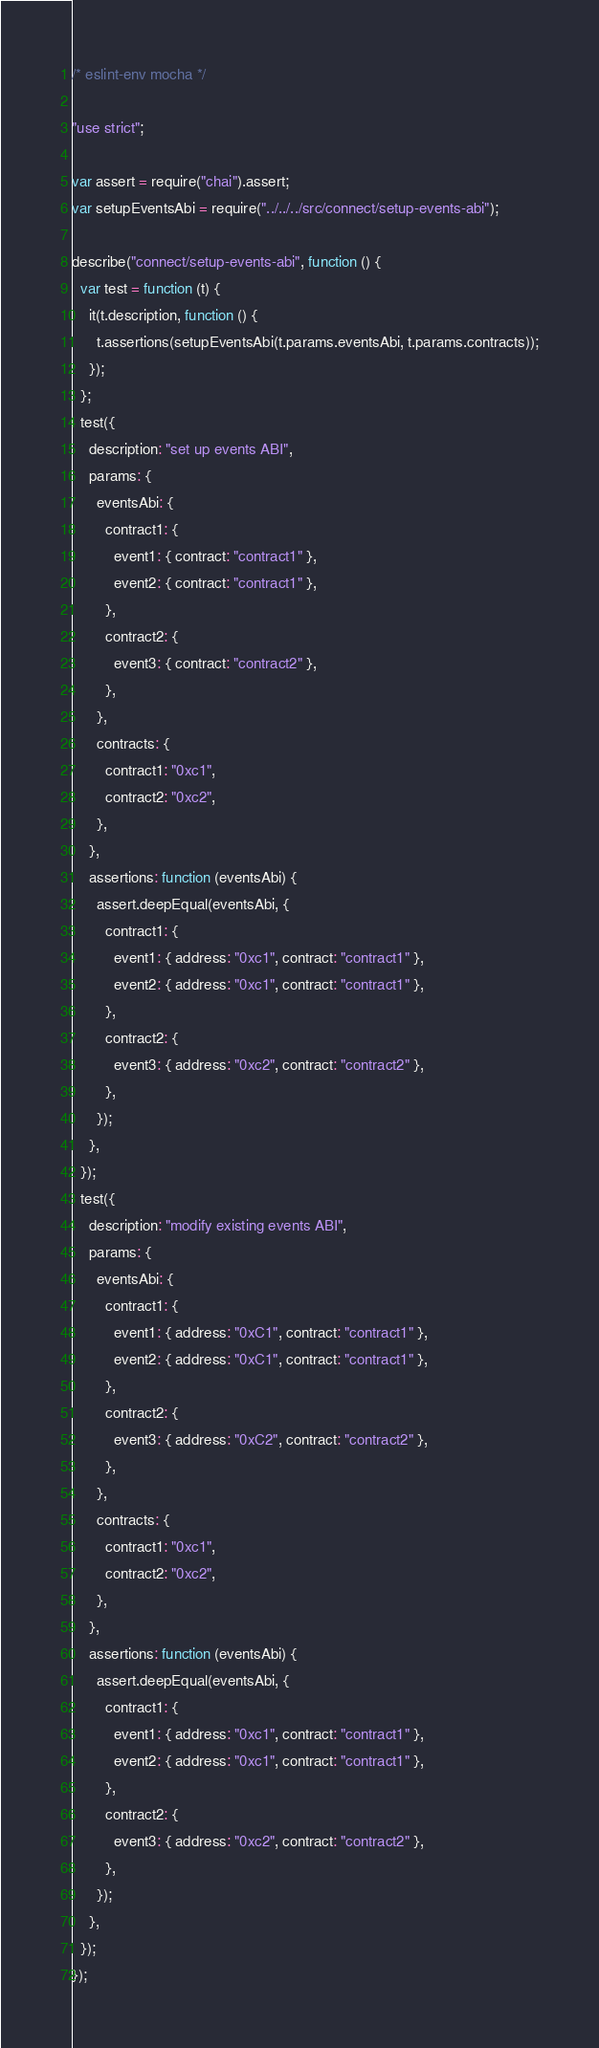<code> <loc_0><loc_0><loc_500><loc_500><_JavaScript_>/* eslint-env mocha */

"use strict";

var assert = require("chai").assert;
var setupEventsAbi = require("../../../src/connect/setup-events-abi");

describe("connect/setup-events-abi", function () {
  var test = function (t) {
    it(t.description, function () {
      t.assertions(setupEventsAbi(t.params.eventsAbi, t.params.contracts));
    });
  };
  test({
    description: "set up events ABI",
    params: {
      eventsAbi: {
        contract1: {
          event1: { contract: "contract1" },
          event2: { contract: "contract1" },
        },
        contract2: {
          event3: { contract: "contract2" },
        },
      },
      contracts: {
        contract1: "0xc1",
        contract2: "0xc2",
      },
    },
    assertions: function (eventsAbi) {
      assert.deepEqual(eventsAbi, {
        contract1: {
          event1: { address: "0xc1", contract: "contract1" },
          event2: { address: "0xc1", contract: "contract1" },
        },
        contract2: {
          event3: { address: "0xc2", contract: "contract2" },
        },
      });
    },
  });
  test({
    description: "modify existing events ABI",
    params: {
      eventsAbi: {
        contract1: {
          event1: { address: "0xC1", contract: "contract1" },
          event2: { address: "0xC1", contract: "contract1" },
        },
        contract2: {
          event3: { address: "0xC2", contract: "contract2" },
        },
      },
      contracts: {
        contract1: "0xc1",
        contract2: "0xc2",
      },
    },
    assertions: function (eventsAbi) {
      assert.deepEqual(eventsAbi, {
        contract1: {
          event1: { address: "0xc1", contract: "contract1" },
          event2: { address: "0xc1", contract: "contract1" },
        },
        contract2: {
          event3: { address: "0xc2", contract: "contract2" },
        },
      });
    },
  });
});
</code> 